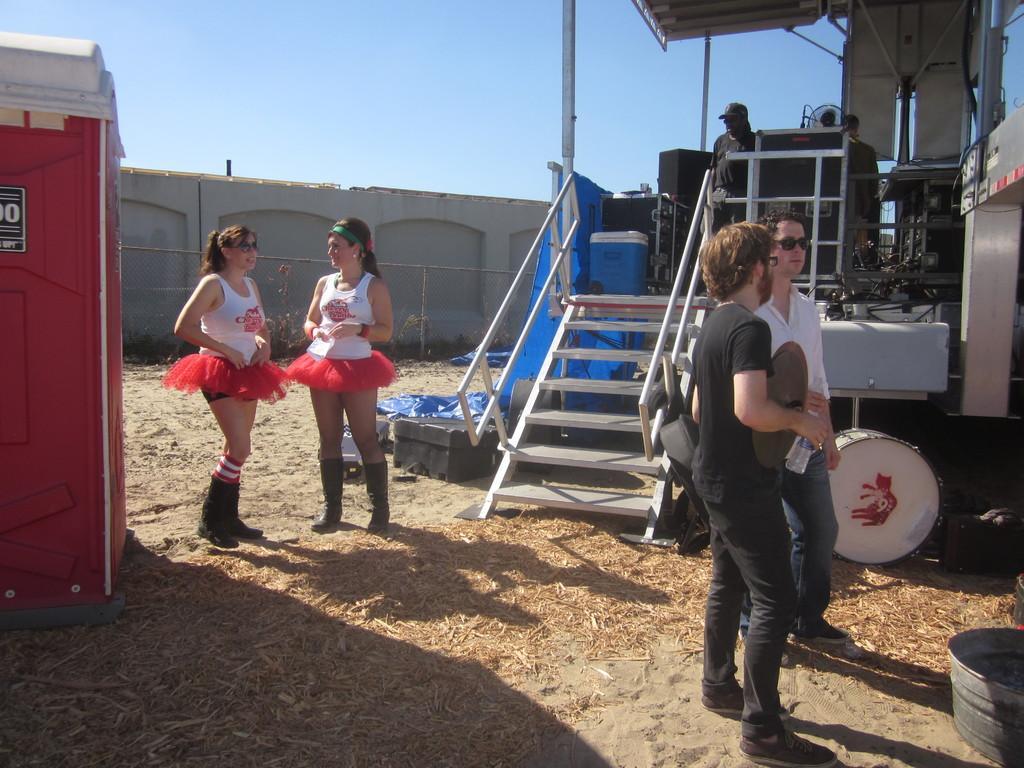Can you describe this image briefly? In this image I can see a person wearing black colored dress is standing and holding few objects in his hand and another person wearing white shirt and jeans is standing. In the background I can see a drum, few stairs, two women wearing white and red colored dress are standing, the wall , red and white colored objects, the stage, few persons standing on the stage and the sky. 